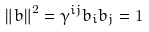Convert formula to latex. <formula><loc_0><loc_0><loc_500><loc_500>\left \| b \right \| ^ { 2 } = \gamma ^ { i j } b _ { i } b _ { j } = 1</formula> 